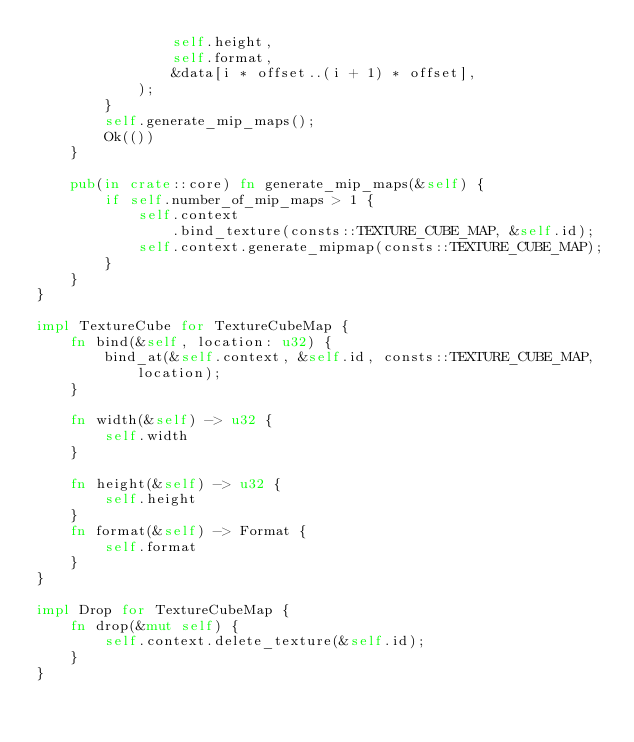Convert code to text. <code><loc_0><loc_0><loc_500><loc_500><_Rust_>                self.height,
                self.format,
                &data[i * offset..(i + 1) * offset],
            );
        }
        self.generate_mip_maps();
        Ok(())
    }

    pub(in crate::core) fn generate_mip_maps(&self) {
        if self.number_of_mip_maps > 1 {
            self.context
                .bind_texture(consts::TEXTURE_CUBE_MAP, &self.id);
            self.context.generate_mipmap(consts::TEXTURE_CUBE_MAP);
        }
    }
}

impl TextureCube for TextureCubeMap {
    fn bind(&self, location: u32) {
        bind_at(&self.context, &self.id, consts::TEXTURE_CUBE_MAP, location);
    }

    fn width(&self) -> u32 {
        self.width
    }

    fn height(&self) -> u32 {
        self.height
    }
    fn format(&self) -> Format {
        self.format
    }
}

impl Drop for TextureCubeMap {
    fn drop(&mut self) {
        self.context.delete_texture(&self.id);
    }
}
</code> 